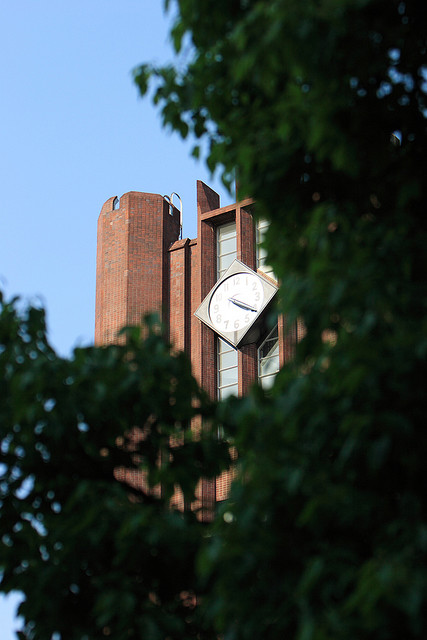Identify the text contained in this image. 11 10 9 8 7 6 5 4 3 2 1 12 